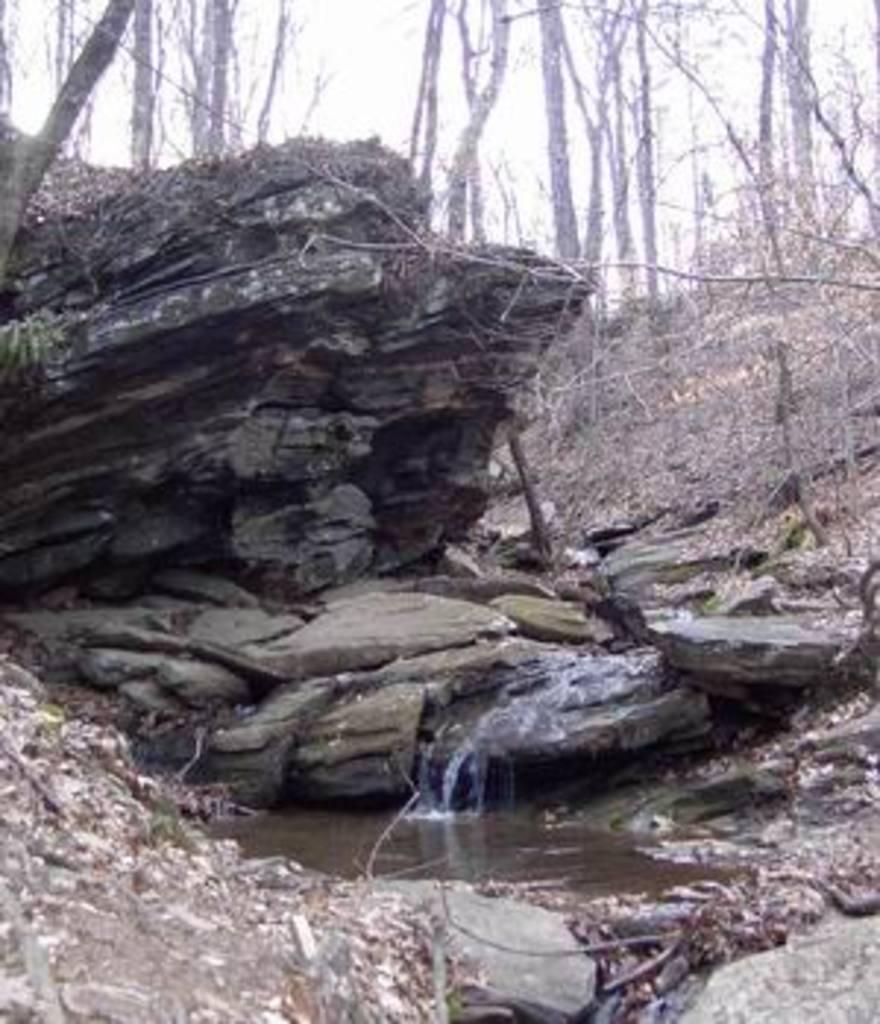Can you describe this image briefly? In this image I can see water in the front and in the background I can see few stones and number of trees. 